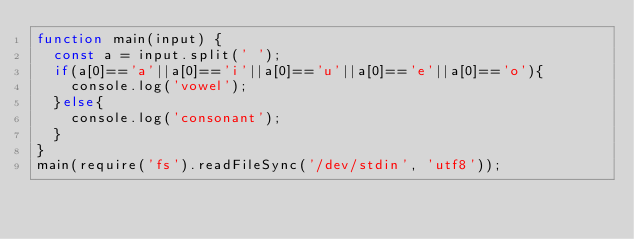<code> <loc_0><loc_0><loc_500><loc_500><_JavaScript_>function main(input) {
  const a = input.split(' ');
  if(a[0]=='a'||a[0]=='i'||a[0]=='u'||a[0]=='e'||a[0]=='o'){
    console.log('vowel');
  }else{
    console.log('consonant');
  }
}
main(require('fs').readFileSync('/dev/stdin', 'utf8'));
</code> 